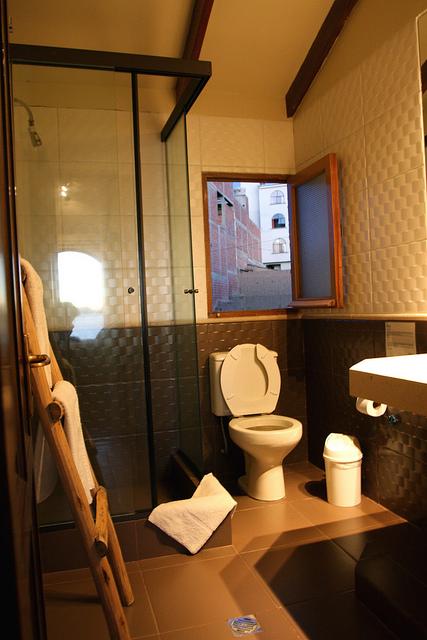Do you need to use this?
Write a very short answer. Yes. Does this room have a window?
Answer briefly. Yes. Is the water running?
Be succinct. No. What is this rom used for?
Keep it brief. Bathroom. 